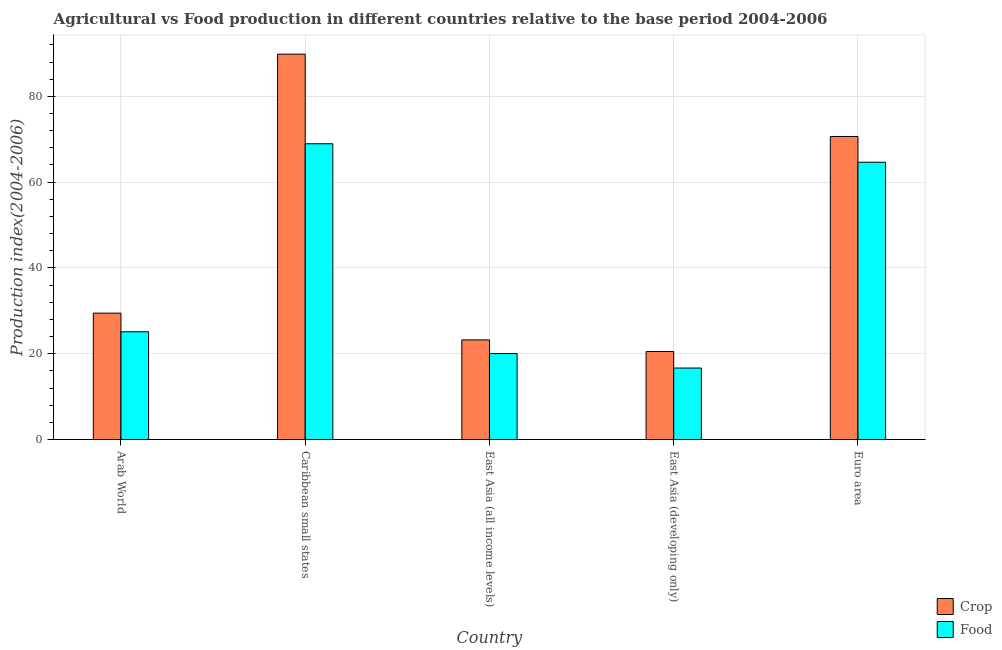How many different coloured bars are there?
Offer a very short reply. 2. How many groups of bars are there?
Make the answer very short. 5. Are the number of bars per tick equal to the number of legend labels?
Ensure brevity in your answer.  Yes. Are the number of bars on each tick of the X-axis equal?
Provide a short and direct response. Yes. How many bars are there on the 1st tick from the left?
Your answer should be compact. 2. How many bars are there on the 4th tick from the right?
Offer a terse response. 2. What is the label of the 1st group of bars from the left?
Offer a very short reply. Arab World. What is the crop production index in Caribbean small states?
Ensure brevity in your answer.  89.84. Across all countries, what is the maximum food production index?
Your answer should be compact. 68.95. Across all countries, what is the minimum crop production index?
Your answer should be very brief. 20.51. In which country was the crop production index maximum?
Offer a very short reply. Caribbean small states. In which country was the food production index minimum?
Ensure brevity in your answer.  East Asia (developing only). What is the total food production index in the graph?
Give a very brief answer. 195.4. What is the difference between the food production index in Arab World and that in Euro area?
Offer a terse response. -39.53. What is the difference between the crop production index in Euro area and the food production index in Arab World?
Your answer should be compact. 45.53. What is the average crop production index per country?
Your answer should be very brief. 46.74. What is the difference between the crop production index and food production index in Caribbean small states?
Make the answer very short. 20.89. What is the ratio of the crop production index in Arab World to that in Caribbean small states?
Keep it short and to the point. 0.33. Is the difference between the crop production index in Caribbean small states and Euro area greater than the difference between the food production index in Caribbean small states and Euro area?
Give a very brief answer. Yes. What is the difference between the highest and the second highest food production index?
Your answer should be very brief. 4.31. What is the difference between the highest and the lowest crop production index?
Your response must be concise. 69.32. In how many countries, is the crop production index greater than the average crop production index taken over all countries?
Offer a terse response. 2. What does the 2nd bar from the left in Caribbean small states represents?
Provide a short and direct response. Food. What does the 2nd bar from the right in Arab World represents?
Your answer should be compact. Crop. Does the graph contain any zero values?
Your response must be concise. No. How many legend labels are there?
Give a very brief answer. 2. What is the title of the graph?
Give a very brief answer. Agricultural vs Food production in different countries relative to the base period 2004-2006. What is the label or title of the X-axis?
Your answer should be very brief. Country. What is the label or title of the Y-axis?
Provide a succinct answer. Production index(2004-2006). What is the Production index(2004-2006) in Crop in Arab World?
Provide a succinct answer. 29.46. What is the Production index(2004-2006) of Food in Arab World?
Provide a succinct answer. 25.11. What is the Production index(2004-2006) of Crop in Caribbean small states?
Offer a very short reply. 89.84. What is the Production index(2004-2006) of Food in Caribbean small states?
Offer a very short reply. 68.95. What is the Production index(2004-2006) of Crop in East Asia (all income levels)?
Keep it short and to the point. 23.22. What is the Production index(2004-2006) in Food in East Asia (all income levels)?
Your response must be concise. 20.03. What is the Production index(2004-2006) of Crop in East Asia (developing only)?
Offer a very short reply. 20.51. What is the Production index(2004-2006) of Food in East Asia (developing only)?
Your response must be concise. 16.66. What is the Production index(2004-2006) in Crop in Euro area?
Offer a very short reply. 70.64. What is the Production index(2004-2006) of Food in Euro area?
Offer a terse response. 64.64. Across all countries, what is the maximum Production index(2004-2006) of Crop?
Give a very brief answer. 89.84. Across all countries, what is the maximum Production index(2004-2006) of Food?
Your response must be concise. 68.95. Across all countries, what is the minimum Production index(2004-2006) of Crop?
Offer a terse response. 20.51. Across all countries, what is the minimum Production index(2004-2006) in Food?
Provide a short and direct response. 16.66. What is the total Production index(2004-2006) of Crop in the graph?
Give a very brief answer. 233.68. What is the total Production index(2004-2006) in Food in the graph?
Your answer should be compact. 195.4. What is the difference between the Production index(2004-2006) in Crop in Arab World and that in Caribbean small states?
Provide a short and direct response. -60.37. What is the difference between the Production index(2004-2006) of Food in Arab World and that in Caribbean small states?
Give a very brief answer. -43.83. What is the difference between the Production index(2004-2006) of Crop in Arab World and that in East Asia (all income levels)?
Your answer should be compact. 6.24. What is the difference between the Production index(2004-2006) in Food in Arab World and that in East Asia (all income levels)?
Give a very brief answer. 5.08. What is the difference between the Production index(2004-2006) of Crop in Arab World and that in East Asia (developing only)?
Your response must be concise. 8.95. What is the difference between the Production index(2004-2006) of Food in Arab World and that in East Asia (developing only)?
Your response must be concise. 8.45. What is the difference between the Production index(2004-2006) of Crop in Arab World and that in Euro area?
Ensure brevity in your answer.  -41.18. What is the difference between the Production index(2004-2006) of Food in Arab World and that in Euro area?
Ensure brevity in your answer.  -39.53. What is the difference between the Production index(2004-2006) in Crop in Caribbean small states and that in East Asia (all income levels)?
Your answer should be compact. 66.61. What is the difference between the Production index(2004-2006) in Food in Caribbean small states and that in East Asia (all income levels)?
Provide a short and direct response. 48.91. What is the difference between the Production index(2004-2006) of Crop in Caribbean small states and that in East Asia (developing only)?
Keep it short and to the point. 69.32. What is the difference between the Production index(2004-2006) in Food in Caribbean small states and that in East Asia (developing only)?
Your answer should be compact. 52.28. What is the difference between the Production index(2004-2006) of Crop in Caribbean small states and that in Euro area?
Your answer should be compact. 19.2. What is the difference between the Production index(2004-2006) in Food in Caribbean small states and that in Euro area?
Offer a very short reply. 4.31. What is the difference between the Production index(2004-2006) of Crop in East Asia (all income levels) and that in East Asia (developing only)?
Your answer should be very brief. 2.71. What is the difference between the Production index(2004-2006) of Food in East Asia (all income levels) and that in East Asia (developing only)?
Your response must be concise. 3.37. What is the difference between the Production index(2004-2006) in Crop in East Asia (all income levels) and that in Euro area?
Give a very brief answer. -47.42. What is the difference between the Production index(2004-2006) in Food in East Asia (all income levels) and that in Euro area?
Provide a short and direct response. -44.61. What is the difference between the Production index(2004-2006) in Crop in East Asia (developing only) and that in Euro area?
Your response must be concise. -50.13. What is the difference between the Production index(2004-2006) in Food in East Asia (developing only) and that in Euro area?
Give a very brief answer. -47.98. What is the difference between the Production index(2004-2006) in Crop in Arab World and the Production index(2004-2006) in Food in Caribbean small states?
Offer a terse response. -39.49. What is the difference between the Production index(2004-2006) in Crop in Arab World and the Production index(2004-2006) in Food in East Asia (all income levels)?
Your response must be concise. 9.43. What is the difference between the Production index(2004-2006) of Crop in Arab World and the Production index(2004-2006) of Food in East Asia (developing only)?
Offer a very short reply. 12.8. What is the difference between the Production index(2004-2006) in Crop in Arab World and the Production index(2004-2006) in Food in Euro area?
Make the answer very short. -35.18. What is the difference between the Production index(2004-2006) of Crop in Caribbean small states and the Production index(2004-2006) of Food in East Asia (all income levels)?
Provide a short and direct response. 69.8. What is the difference between the Production index(2004-2006) of Crop in Caribbean small states and the Production index(2004-2006) of Food in East Asia (developing only)?
Your answer should be compact. 73.17. What is the difference between the Production index(2004-2006) in Crop in Caribbean small states and the Production index(2004-2006) in Food in Euro area?
Give a very brief answer. 25.2. What is the difference between the Production index(2004-2006) in Crop in East Asia (all income levels) and the Production index(2004-2006) in Food in East Asia (developing only)?
Ensure brevity in your answer.  6.56. What is the difference between the Production index(2004-2006) in Crop in East Asia (all income levels) and the Production index(2004-2006) in Food in Euro area?
Your answer should be very brief. -41.42. What is the difference between the Production index(2004-2006) in Crop in East Asia (developing only) and the Production index(2004-2006) in Food in Euro area?
Your response must be concise. -44.13. What is the average Production index(2004-2006) of Crop per country?
Provide a short and direct response. 46.74. What is the average Production index(2004-2006) of Food per country?
Provide a succinct answer. 39.08. What is the difference between the Production index(2004-2006) of Crop and Production index(2004-2006) of Food in Arab World?
Provide a succinct answer. 4.35. What is the difference between the Production index(2004-2006) in Crop and Production index(2004-2006) in Food in Caribbean small states?
Your answer should be very brief. 20.89. What is the difference between the Production index(2004-2006) of Crop and Production index(2004-2006) of Food in East Asia (all income levels)?
Offer a terse response. 3.19. What is the difference between the Production index(2004-2006) of Crop and Production index(2004-2006) of Food in East Asia (developing only)?
Your response must be concise. 3.85. What is the difference between the Production index(2004-2006) of Crop and Production index(2004-2006) of Food in Euro area?
Give a very brief answer. 6. What is the ratio of the Production index(2004-2006) in Crop in Arab World to that in Caribbean small states?
Your response must be concise. 0.33. What is the ratio of the Production index(2004-2006) in Food in Arab World to that in Caribbean small states?
Make the answer very short. 0.36. What is the ratio of the Production index(2004-2006) of Crop in Arab World to that in East Asia (all income levels)?
Offer a very short reply. 1.27. What is the ratio of the Production index(2004-2006) of Food in Arab World to that in East Asia (all income levels)?
Provide a short and direct response. 1.25. What is the ratio of the Production index(2004-2006) of Crop in Arab World to that in East Asia (developing only)?
Your answer should be compact. 1.44. What is the ratio of the Production index(2004-2006) in Food in Arab World to that in East Asia (developing only)?
Offer a terse response. 1.51. What is the ratio of the Production index(2004-2006) in Crop in Arab World to that in Euro area?
Keep it short and to the point. 0.42. What is the ratio of the Production index(2004-2006) of Food in Arab World to that in Euro area?
Offer a very short reply. 0.39. What is the ratio of the Production index(2004-2006) of Crop in Caribbean small states to that in East Asia (all income levels)?
Your answer should be compact. 3.87. What is the ratio of the Production index(2004-2006) in Food in Caribbean small states to that in East Asia (all income levels)?
Ensure brevity in your answer.  3.44. What is the ratio of the Production index(2004-2006) in Crop in Caribbean small states to that in East Asia (developing only)?
Ensure brevity in your answer.  4.38. What is the ratio of the Production index(2004-2006) in Food in Caribbean small states to that in East Asia (developing only)?
Ensure brevity in your answer.  4.14. What is the ratio of the Production index(2004-2006) in Crop in Caribbean small states to that in Euro area?
Offer a terse response. 1.27. What is the ratio of the Production index(2004-2006) in Food in Caribbean small states to that in Euro area?
Make the answer very short. 1.07. What is the ratio of the Production index(2004-2006) of Crop in East Asia (all income levels) to that in East Asia (developing only)?
Keep it short and to the point. 1.13. What is the ratio of the Production index(2004-2006) in Food in East Asia (all income levels) to that in East Asia (developing only)?
Give a very brief answer. 1.2. What is the ratio of the Production index(2004-2006) in Crop in East Asia (all income levels) to that in Euro area?
Your answer should be very brief. 0.33. What is the ratio of the Production index(2004-2006) in Food in East Asia (all income levels) to that in Euro area?
Your answer should be very brief. 0.31. What is the ratio of the Production index(2004-2006) of Crop in East Asia (developing only) to that in Euro area?
Offer a very short reply. 0.29. What is the ratio of the Production index(2004-2006) in Food in East Asia (developing only) to that in Euro area?
Make the answer very short. 0.26. What is the difference between the highest and the second highest Production index(2004-2006) in Crop?
Your response must be concise. 19.2. What is the difference between the highest and the second highest Production index(2004-2006) in Food?
Keep it short and to the point. 4.31. What is the difference between the highest and the lowest Production index(2004-2006) in Crop?
Make the answer very short. 69.32. What is the difference between the highest and the lowest Production index(2004-2006) in Food?
Keep it short and to the point. 52.28. 